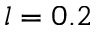<formula> <loc_0><loc_0><loc_500><loc_500>l = 0 . 2</formula> 